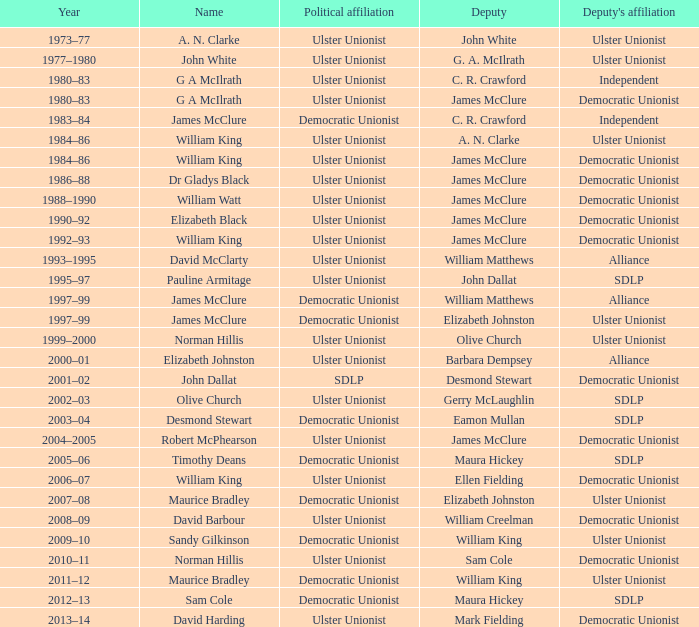What is the Deputy's affiliation in 1992–93? Democratic Unionist. 